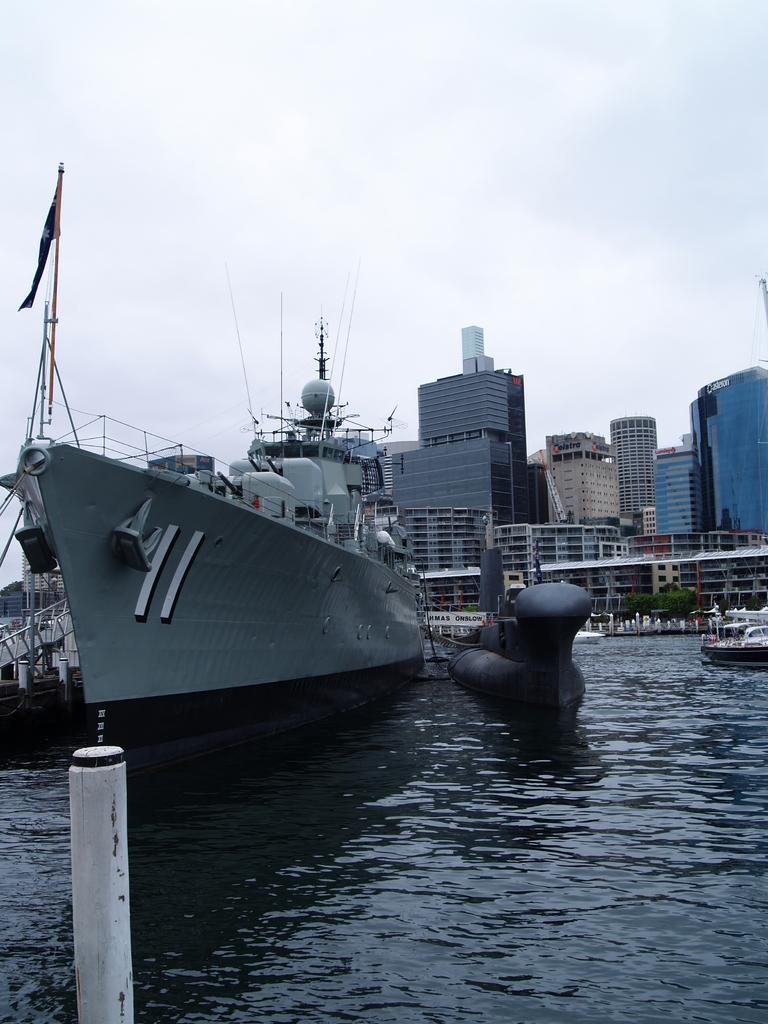Please provide a concise description of this image. In this image there is water and we can see ships on the water. In the background there are buildings. At the top there is sky. 